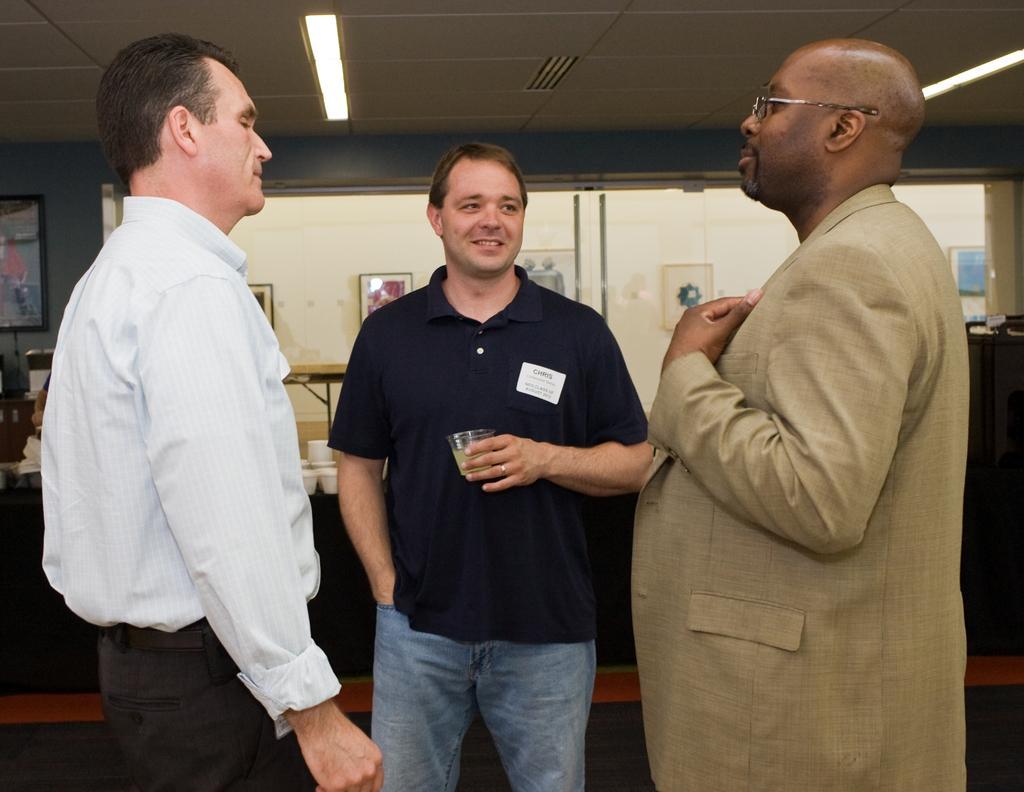Describe this image in one or two sentences. This picture shows the inner view of a room, some photo frames attached to the wall, some different objects are on the surface, two lights attached to the ceiling, some objects are on the table, one table covered with tablecloth, three people standing, one carpet and one person with blue T-shirt holding a glass. 